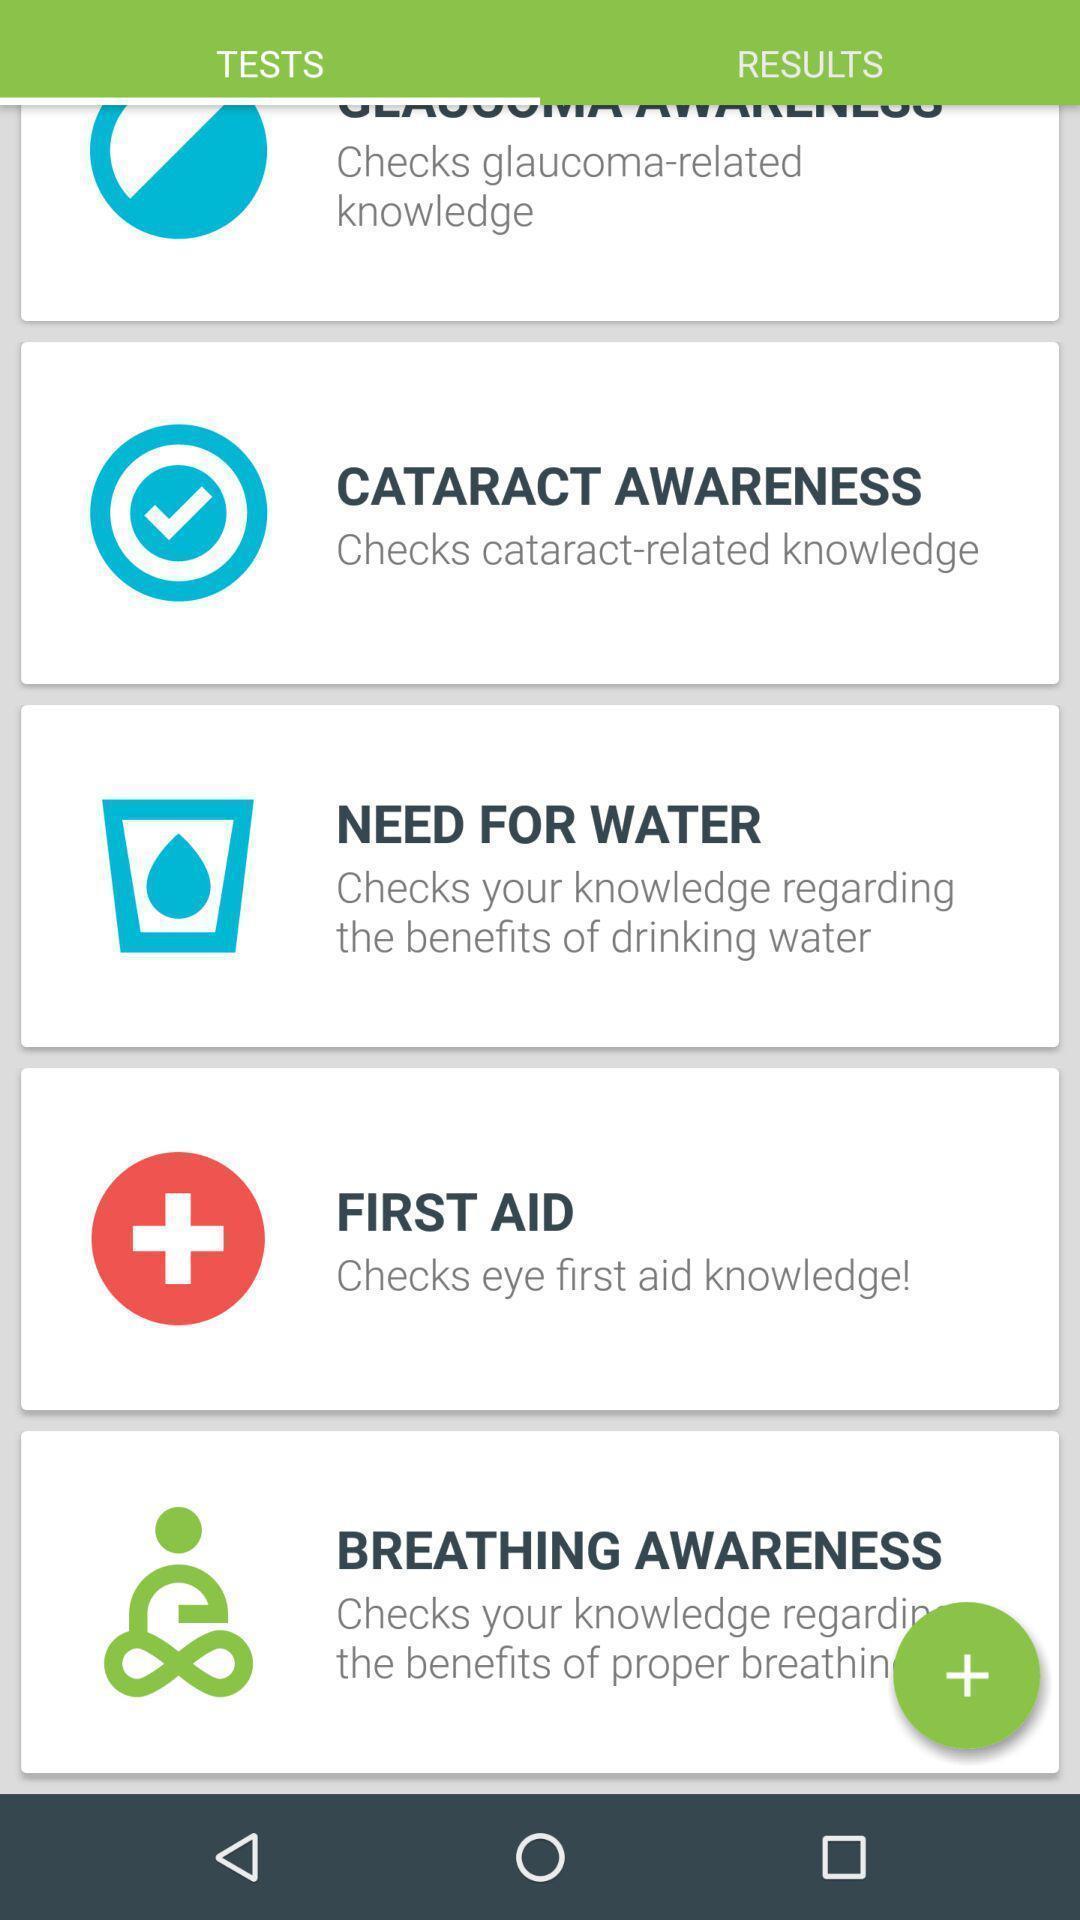Explain the elements present in this screenshot. Page displays list of tests in app. 